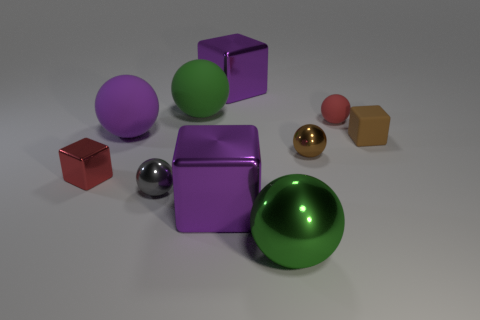Subtract all cyan cubes. How many green balls are left? 2 Subtract all tiny brown balls. How many balls are left? 5 Subtract all green balls. How many balls are left? 4 Subtract 4 balls. How many balls are left? 2 Subtract all cyan cubes. Subtract all yellow balls. How many cubes are left? 4 Subtract all cubes. How many objects are left? 6 Subtract all purple rubber things. Subtract all big green metal objects. How many objects are left? 8 Add 7 purple rubber objects. How many purple rubber objects are left? 8 Add 10 large purple matte cylinders. How many large purple matte cylinders exist? 10 Subtract 0 gray cylinders. How many objects are left? 10 